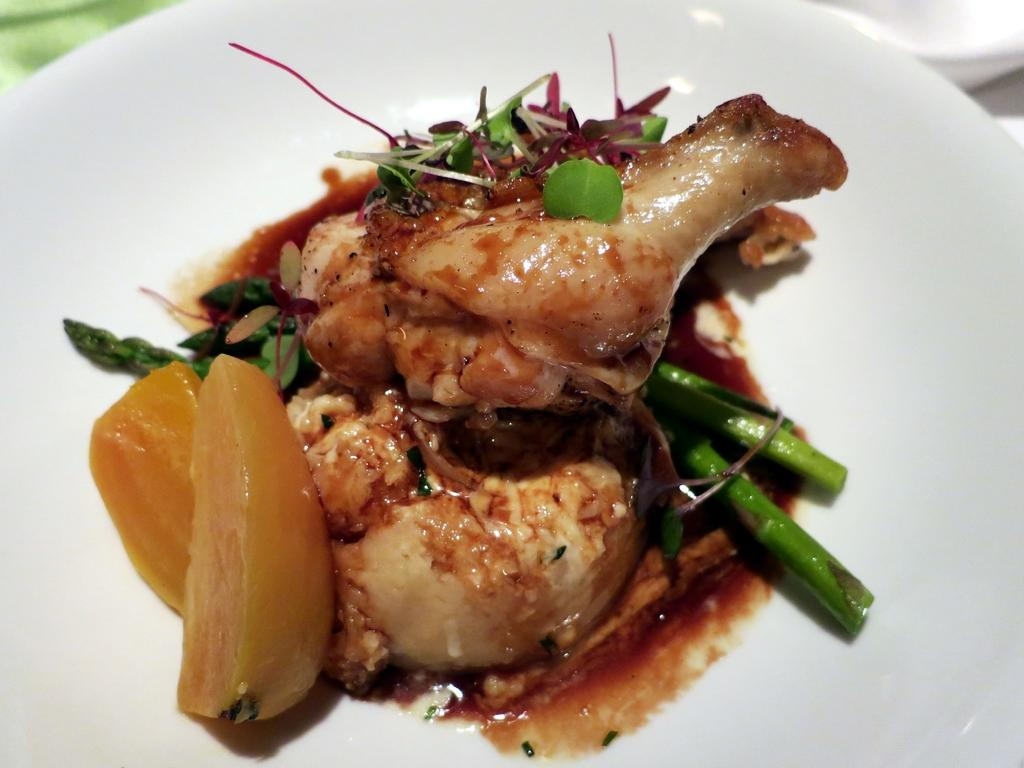What is on the plate that is visible in the image? There is a white plate in the image. What is on top of the white plate? There are different types of food on the plate. What is the color of the food on the plate? The color of the food on the plate is brown. What type of pear is being used as a reward for the dog in the image? There is no dog or pear present in the image. 